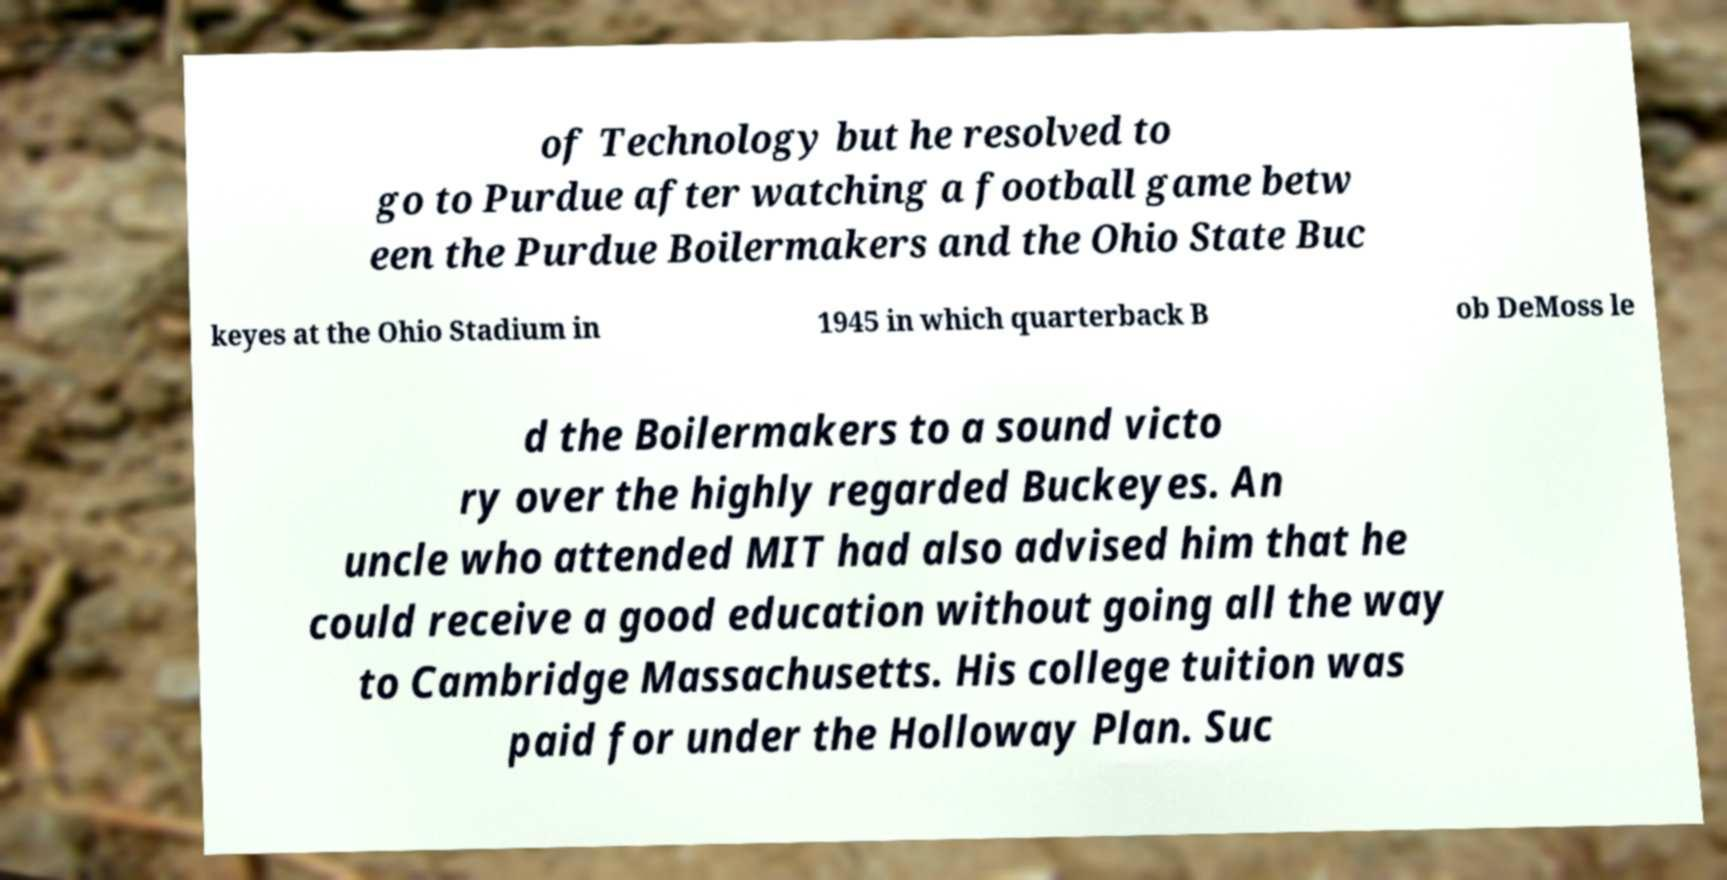I need the written content from this picture converted into text. Can you do that? of Technology but he resolved to go to Purdue after watching a football game betw een the Purdue Boilermakers and the Ohio State Buc keyes at the Ohio Stadium in 1945 in which quarterback B ob DeMoss le d the Boilermakers to a sound victo ry over the highly regarded Buckeyes. An uncle who attended MIT had also advised him that he could receive a good education without going all the way to Cambridge Massachusetts. His college tuition was paid for under the Holloway Plan. Suc 